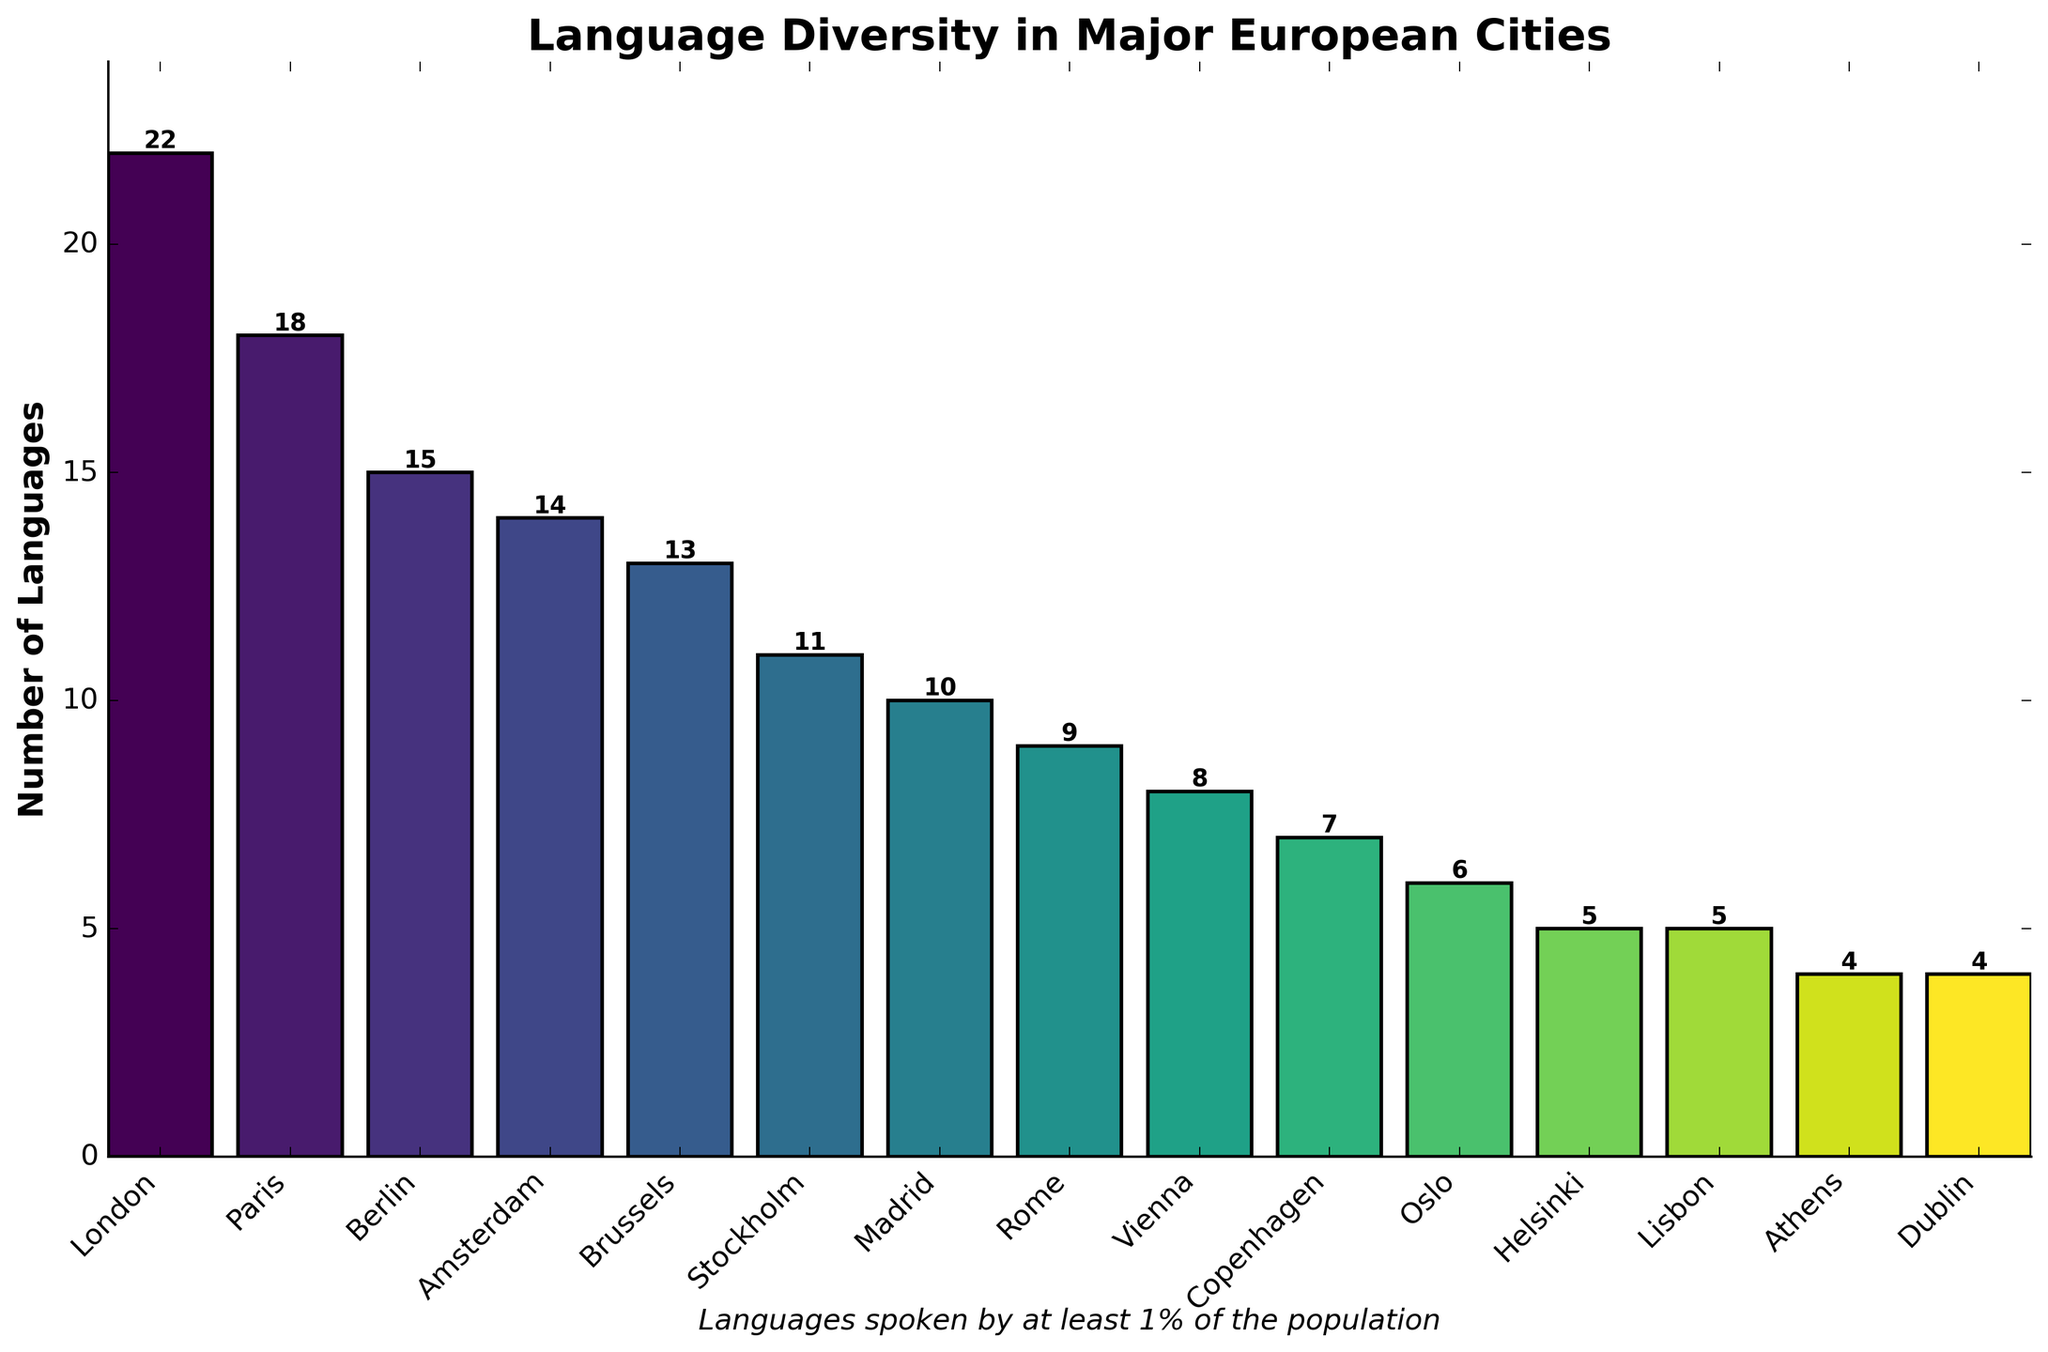Which city has the highest language diversity? The city with the tallest bar in the chart corresponds to London. It has 22 languages, represented by the maximum bar height.
Answer: London Which city has the lowest language diversity? The cities with the shortest bars in the chart correspond to Lisbon, Athens, and Dublin, each having 5, 4, and 4 languages, respectively.
Answer: Athens and Dublin How many cities have more than 10 languages spoken by at least 1% of the population? Count the bars with heights greater than 10. Cities include London, Paris, Berlin, Amsterdam, Brussels, and Stockholm.
Answer: 6 Which city speaks just one more language than Madrid? Madrid has 10 languages. The next highest is Stockholm with 11 languages, as indicated by the bar heights.
Answer: Stockholm What is the difference in the number of languages spoken in Berlin and Amsterdam? Berlin has 15 languages, and Amsterdam has 14 languages. The difference is 15 - 14 = 1.
Answer: 1 Which city has exactly half the number of languages spoken in London? London has 22 languages. The half is 22 / 2 = 11. Stockholm has 11 languages, as indicated by the bar height.
Answer: Stockholm What is the total number of languages spoken across Madrid and Rome combined? Madrid has 10 languages, and Rome has 9 languages. The combined total is 10 + 9 = 19.
Answer: 19 Which city has a higher language diversity, Brussels or Vienna? Compare the bar heights of Brussels (13 languages) and Vienna (8 languages). Brussels has a higher language diversity.
Answer: Brussels What is the average number of languages spoken in Amsterdam, Brussels, and Stockholm? The number of languages for Amsterdam is 14, Brussels is 13, and Stockholm is 11. The average = (14 + 13 + 11) / 3 = 38 / 3 ≈ 12.67.
Answer: 12.67 Is the number of languages spoken in Paris greater than, less than, or equal to that in Berlin? Compare the bar heights of Paris (18 languages) and Berlin (15 languages). Paris has more languages.
Answer: Greater than 